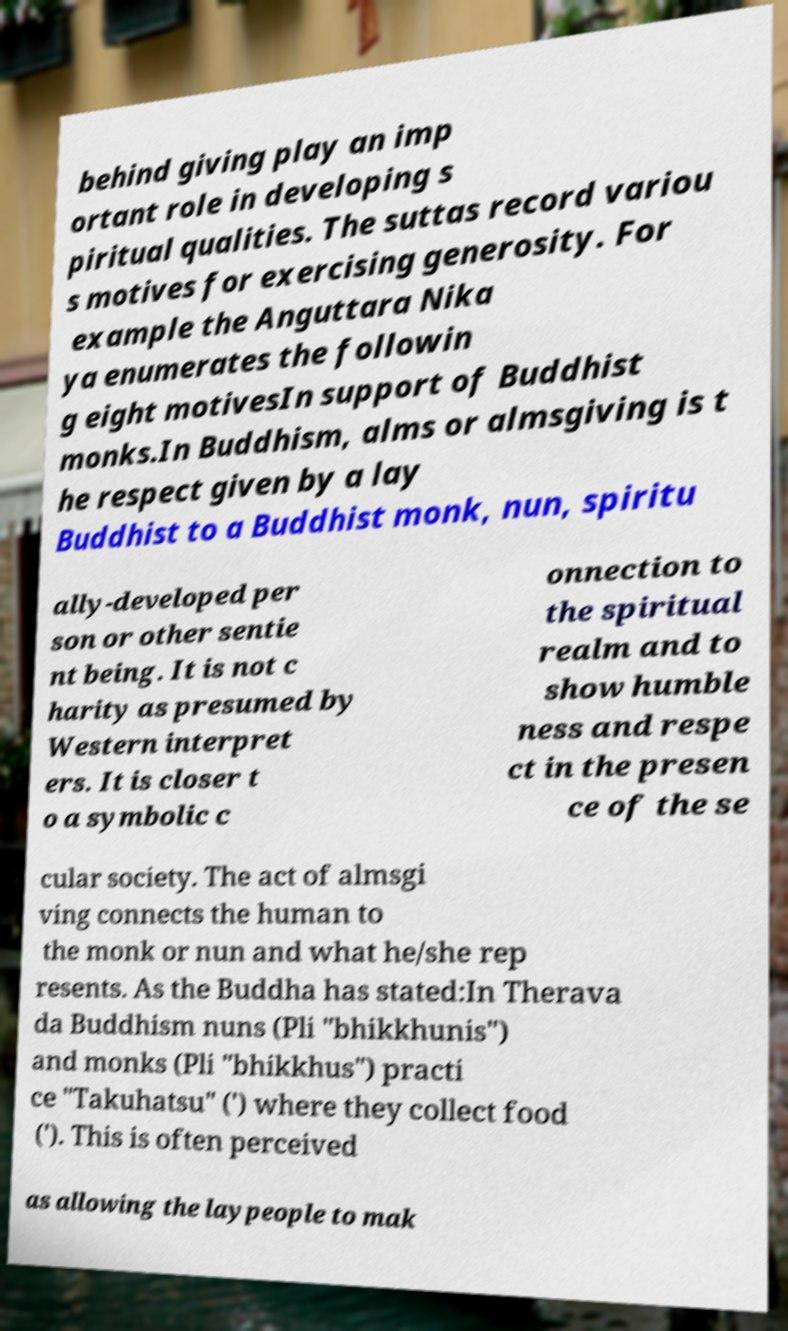What messages or text are displayed in this image? I need them in a readable, typed format. behind giving play an imp ortant role in developing s piritual qualities. The suttas record variou s motives for exercising generosity. For example the Anguttara Nika ya enumerates the followin g eight motivesIn support of Buddhist monks.In Buddhism, alms or almsgiving is t he respect given by a lay Buddhist to a Buddhist monk, nun, spiritu ally-developed per son or other sentie nt being. It is not c harity as presumed by Western interpret ers. It is closer t o a symbolic c onnection to the spiritual realm and to show humble ness and respe ct in the presen ce of the se cular society. The act of almsgi ving connects the human to the monk or nun and what he/she rep resents. As the Buddha has stated:In Therava da Buddhism nuns (Pli "bhikkhunis") and monks (Pli "bhikkhus") practi ce "Takuhatsu" (') where they collect food ('). This is often perceived as allowing the laypeople to mak 